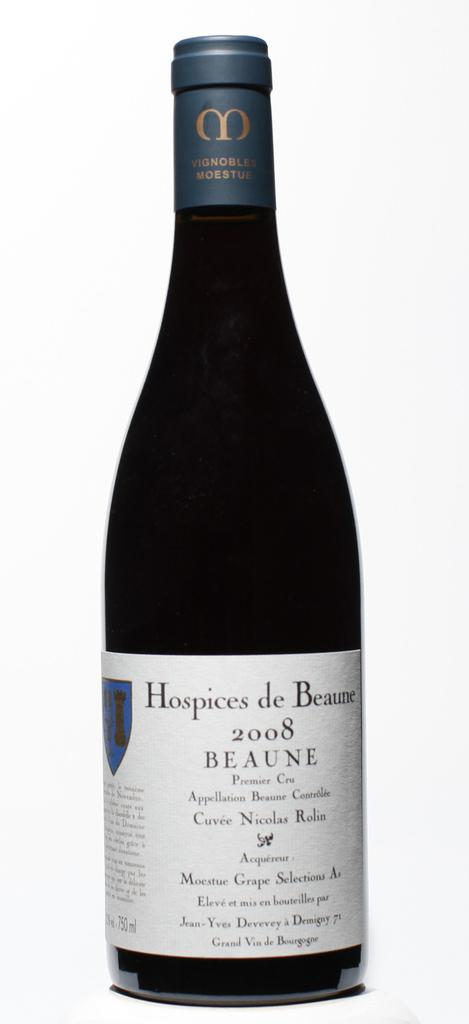What object is present in the picture? There is a bottle in the picture. What is on the bottle? There is a poster on the bottle. What can be found on the poster? The poster contains text. How many cakes are displayed on the poster? There are no cakes present on the poster; it only contains text. What type of zephyr is blowing in the background of the image? There is no mention of a zephyr or any background elements in the image; it only features a bottle with a poster on it. 